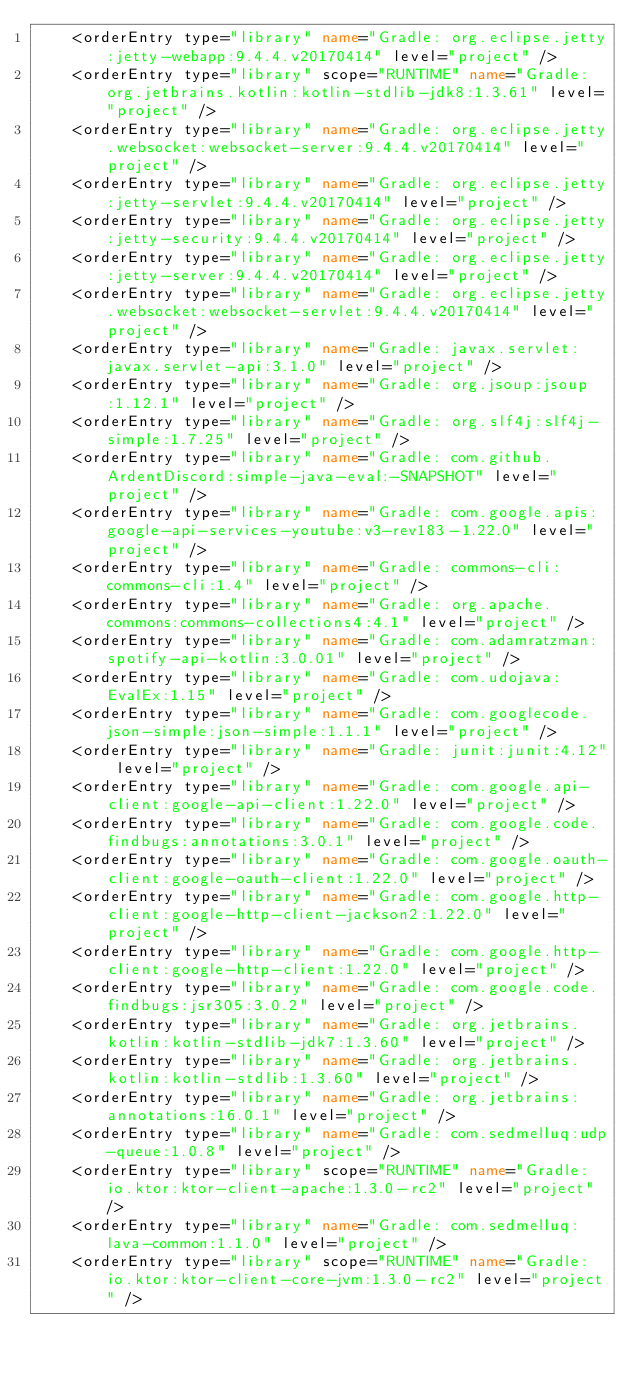Convert code to text. <code><loc_0><loc_0><loc_500><loc_500><_XML_>    <orderEntry type="library" name="Gradle: org.eclipse.jetty:jetty-webapp:9.4.4.v20170414" level="project" />
    <orderEntry type="library" scope="RUNTIME" name="Gradle: org.jetbrains.kotlin:kotlin-stdlib-jdk8:1.3.61" level="project" />
    <orderEntry type="library" name="Gradle: org.eclipse.jetty.websocket:websocket-server:9.4.4.v20170414" level="project" />
    <orderEntry type="library" name="Gradle: org.eclipse.jetty:jetty-servlet:9.4.4.v20170414" level="project" />
    <orderEntry type="library" name="Gradle: org.eclipse.jetty:jetty-security:9.4.4.v20170414" level="project" />
    <orderEntry type="library" name="Gradle: org.eclipse.jetty:jetty-server:9.4.4.v20170414" level="project" />
    <orderEntry type="library" name="Gradle: org.eclipse.jetty.websocket:websocket-servlet:9.4.4.v20170414" level="project" />
    <orderEntry type="library" name="Gradle: javax.servlet:javax.servlet-api:3.1.0" level="project" />
    <orderEntry type="library" name="Gradle: org.jsoup:jsoup:1.12.1" level="project" />
    <orderEntry type="library" name="Gradle: org.slf4j:slf4j-simple:1.7.25" level="project" />
    <orderEntry type="library" name="Gradle: com.github.ArdentDiscord:simple-java-eval:-SNAPSHOT" level="project" />
    <orderEntry type="library" name="Gradle: com.google.apis:google-api-services-youtube:v3-rev183-1.22.0" level="project" />
    <orderEntry type="library" name="Gradle: commons-cli:commons-cli:1.4" level="project" />
    <orderEntry type="library" name="Gradle: org.apache.commons:commons-collections4:4.1" level="project" />
    <orderEntry type="library" name="Gradle: com.adamratzman:spotify-api-kotlin:3.0.01" level="project" />
    <orderEntry type="library" name="Gradle: com.udojava:EvalEx:1.15" level="project" />
    <orderEntry type="library" name="Gradle: com.googlecode.json-simple:json-simple:1.1.1" level="project" />
    <orderEntry type="library" name="Gradle: junit:junit:4.12" level="project" />
    <orderEntry type="library" name="Gradle: com.google.api-client:google-api-client:1.22.0" level="project" />
    <orderEntry type="library" name="Gradle: com.google.code.findbugs:annotations:3.0.1" level="project" />
    <orderEntry type="library" name="Gradle: com.google.oauth-client:google-oauth-client:1.22.0" level="project" />
    <orderEntry type="library" name="Gradle: com.google.http-client:google-http-client-jackson2:1.22.0" level="project" />
    <orderEntry type="library" name="Gradle: com.google.http-client:google-http-client:1.22.0" level="project" />
    <orderEntry type="library" name="Gradle: com.google.code.findbugs:jsr305:3.0.2" level="project" />
    <orderEntry type="library" name="Gradle: org.jetbrains.kotlin:kotlin-stdlib-jdk7:1.3.60" level="project" />
    <orderEntry type="library" name="Gradle: org.jetbrains.kotlin:kotlin-stdlib:1.3.60" level="project" />
    <orderEntry type="library" name="Gradle: org.jetbrains:annotations:16.0.1" level="project" />
    <orderEntry type="library" name="Gradle: com.sedmelluq:udp-queue:1.0.8" level="project" />
    <orderEntry type="library" scope="RUNTIME" name="Gradle: io.ktor:ktor-client-apache:1.3.0-rc2" level="project" />
    <orderEntry type="library" name="Gradle: com.sedmelluq:lava-common:1.1.0" level="project" />
    <orderEntry type="library" scope="RUNTIME" name="Gradle: io.ktor:ktor-client-core-jvm:1.3.0-rc2" level="project" /></code> 